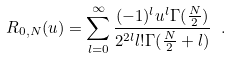<formula> <loc_0><loc_0><loc_500><loc_500>R _ { 0 , N } ( u ) = \sum _ { l = 0 } ^ { \infty } \frac { ( - 1 ) ^ { l } u ^ { l } \Gamma ( \frac { N } { 2 } ) } { 2 ^ { 2 l } l ! \Gamma ( \frac { N } { 2 } + l ) } \ .</formula> 